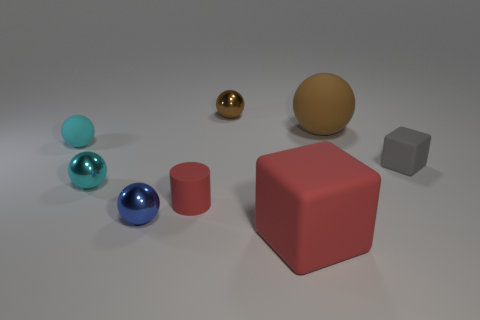Subtract all blue spheres. How many spheres are left? 4 Subtract all large balls. How many balls are left? 4 Add 1 tiny cyan metal things. How many objects exist? 9 Subtract all blue balls. Subtract all cyan cylinders. How many balls are left? 4 Subtract all cylinders. How many objects are left? 7 Subtract 0 purple balls. How many objects are left? 8 Subtract all large balls. Subtract all red matte cubes. How many objects are left? 6 Add 2 tiny brown things. How many tiny brown things are left? 3 Add 3 red rubber cubes. How many red rubber cubes exist? 4 